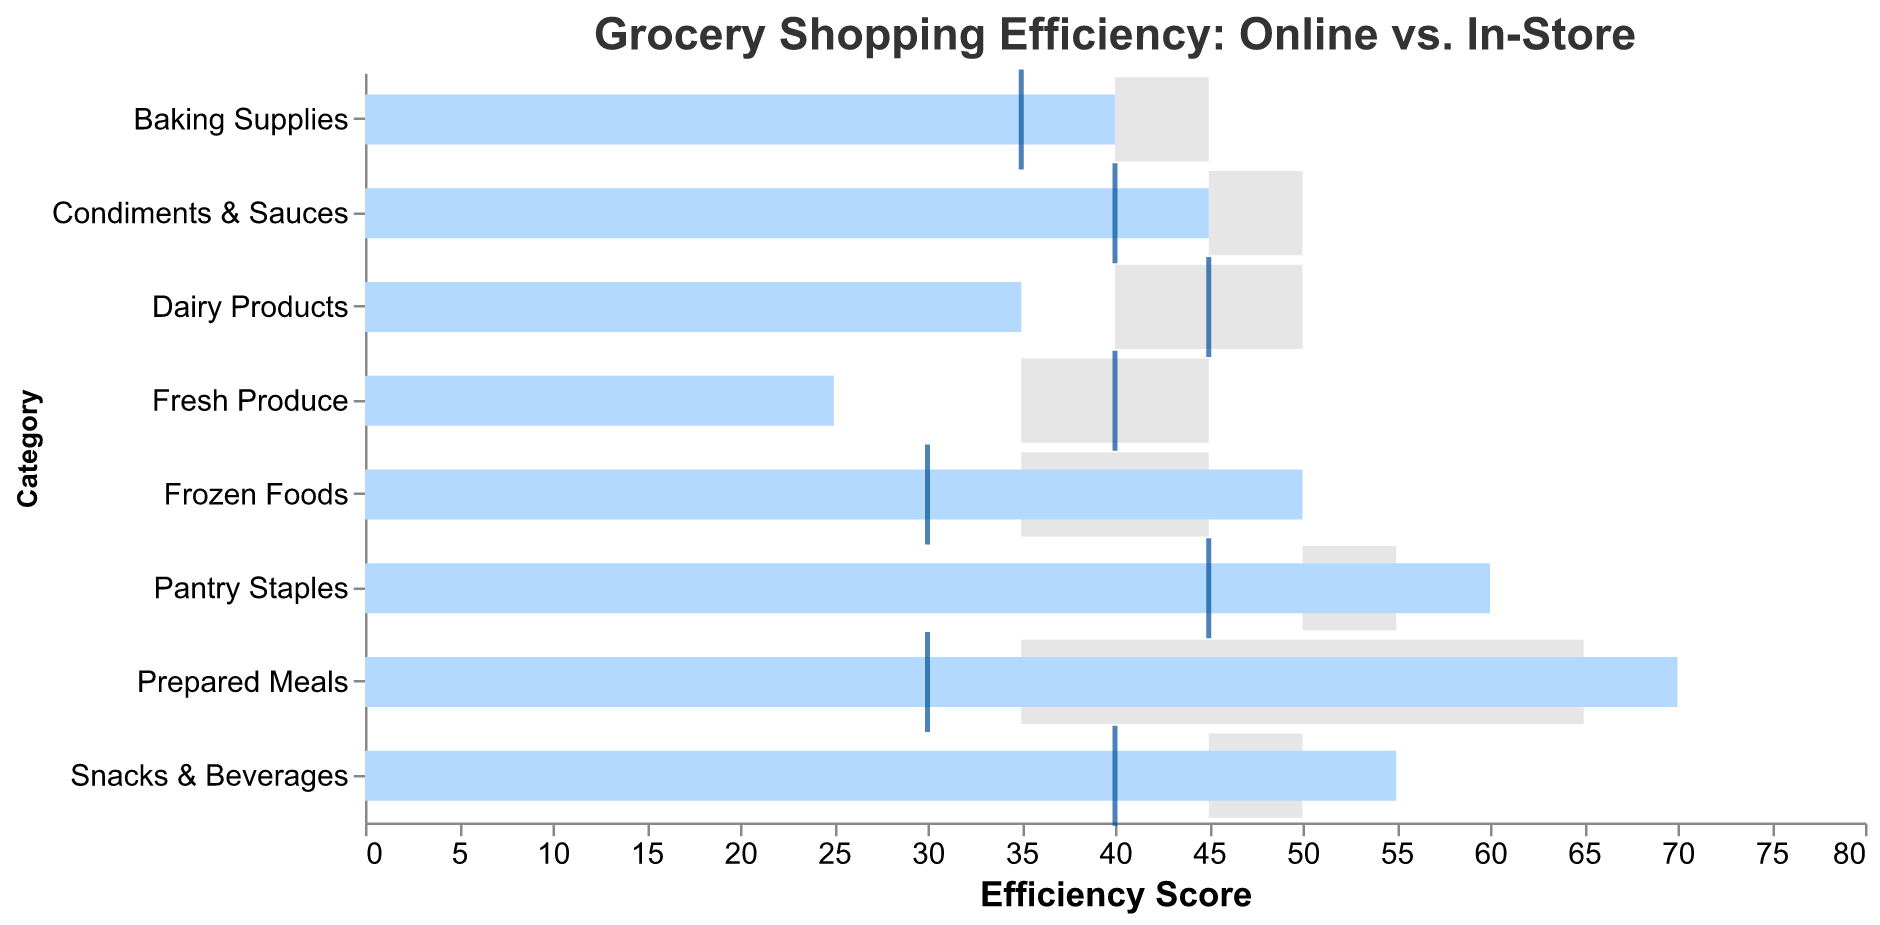What's the title of the figure? The title is displayed at the top of the figure in a larger font size, reading "Grocery Shopping Efficiency: Online vs. In-Store".
Answer: Grocery Shopping Efficiency: Online vs. In-Store How many product categories are shown in the figure? The y-axis lists the product categories, and there are 8 distinct labels visible from "Fresh Produce" to "Condiments & Sauces".
Answer: 8 Which product category has the highest online actual efficiency? Look for the highest bar colored in light blue representing online actual efficiency. "Prepared Meals" has the highest bar reaching 70.
Answer: Prepared Meals What is the difference between online actual and target efficiency for "Fresh Produce"? Subtract the online actual value from the target value for "Fresh Produce": 35 - 25 = 10.
Answer: 10 Which product category shows a better in-store efficiency than online efficiency based on the actual scores? Compare the blue bars (online actual) and dark blue ticks (in-store actual). "Dairy Products" has 45 in-store vs. 35 online.
Answer: Dairy Products Are there any product categories where the online actual efficiency exceeds the online target efficiency? Compare the blue bars with the grey bar segments for each Online Target. "Pantry Staples," "Frozen Foods," "Snacks & Beverages," and "Prepared Meals" have online actual greater than the target.
Answer: Pantry Staples, Frozen Foods, Snacks & Beverages, Prepared Meals For which product category is the difference in actual efficiencies (online vs. in-store) the largest? Calculate the absolute difference for each category. "Prepared Meals" has the largest difference (70 online - 30 in-store = 40).
Answer: Prepared Meals Which product categories meet their in-store target efficiency exactly? Check if any dark blue ticks align with the grey bar segments' right edge. None of the in-store actual values meet their in-store targets exactly.
Answer: None What is the average online target efficiency across all product categories? Sum the online target values and divide by the number of categories: (35 + 55 + 45 + 40 + 50 + 65 + 45 + 50) / 8 = 48.125.
Answer: 48.125 Which category has the smallest difference between in-store actual and target efficiencies? Find the smallest absolute difference between in-store actual and target: "Frozen Foods" (35 - 30 = 5).
Answer: Frozen Foods 